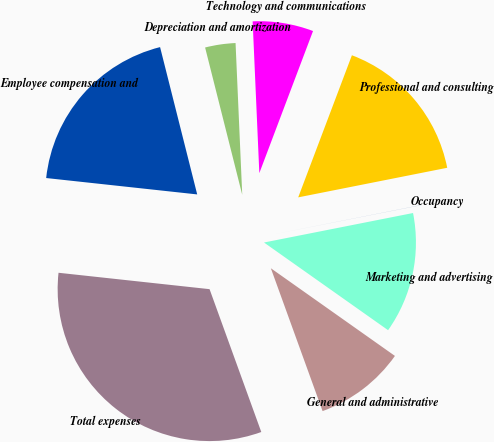Convert chart. <chart><loc_0><loc_0><loc_500><loc_500><pie_chart><fcel>Employee compensation and<fcel>Depreciation and amortization<fcel>Technology and communications<fcel>Professional and consulting<fcel>Occupancy<fcel>Marketing and advertising<fcel>General and administrative<fcel>Total expenses<nl><fcel>19.35%<fcel>3.23%<fcel>6.45%<fcel>16.13%<fcel>0.01%<fcel>12.9%<fcel>9.68%<fcel>32.25%<nl></chart> 